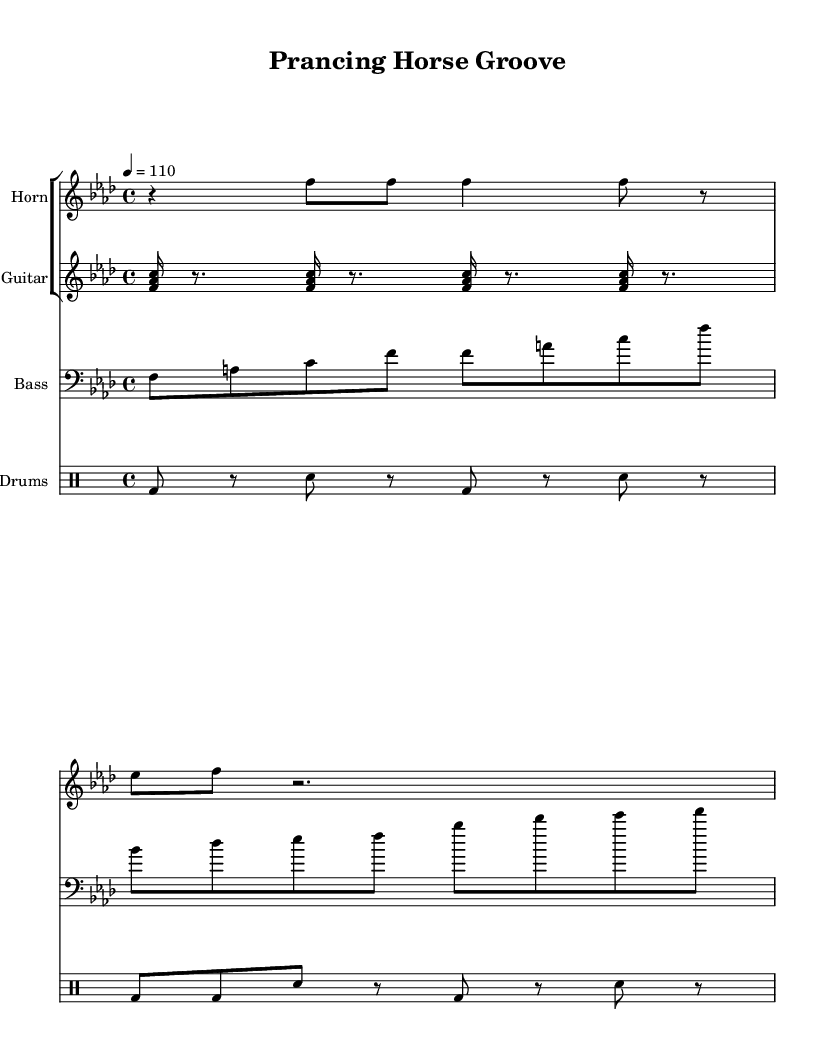What is the key signature of this music? The key signature is indicated by the sharp or flat symbols at the beginning of the staff. In this case, the music is in F minor, which has four flats.
Answer: F minor What is the time signature of this music? The time signature is found at the beginning of the piece, indicating how many beats are in each measure. Here, it shows 4/4, meaning there are four beats in each measure.
Answer: 4/4 What is the tempo marking of the piece? The tempo marking is shown near the beginning of the music, indicating the speed at which it should be played. This piece has a tempo marking of quarter note equals 110.
Answer: 110 How many measures does the horn section cover? To determine the number of measures for the horn section, I count the number of groups separated by vertical bar lines. The horn section has two measures in total in the provided music.
Answer: 2 Which instrument plays the bass line? The instrument designation is located at the beginning of the staff for each part. The bass line is played by the instrument labeled "Bass."
Answer: Bass What type of rhythm is primarily used in the drum groove? By examining the drum groove notation, it is clear that the primary rhythm consists of a repeated pattern incorporating bass drum and snare hits. This aligns with common funk rhythms, which are typically syncopated.
Answer: Syncopated What chord voicing is indicated for the guitar part? The guitar part is notated as a set of notes played simultaneously, specifically showing voicings of F, A, and C, which form an F major chord.
Answer: F major 